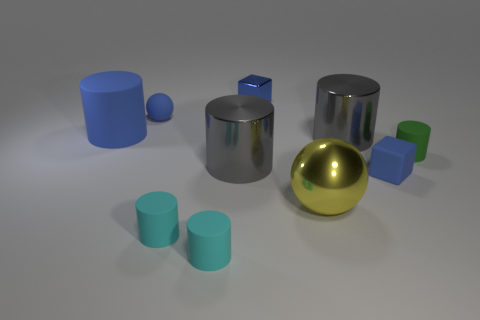What shape is the tiny metal thing that is the same color as the large rubber cylinder?
Your answer should be compact. Cube. How many small brown things have the same shape as the large blue rubber thing?
Provide a succinct answer. 0. There is a matte object that is the same size as the metal ball; what color is it?
Provide a succinct answer. Blue. Is there a yellow matte thing?
Your answer should be very brief. No. What is the shape of the tiny blue rubber thing that is to the left of the large metallic ball?
Provide a short and direct response. Sphere. How many blue objects are in front of the metal cube and on the right side of the rubber ball?
Make the answer very short. 1. Are there any small cylinders made of the same material as the large yellow object?
Your answer should be very brief. No. There is a rubber cylinder that is the same color as the metal cube; what size is it?
Your answer should be compact. Large. What number of cubes are either small green objects or tiny cyan objects?
Give a very brief answer. 0. The blue shiny object is what size?
Offer a terse response. Small. 